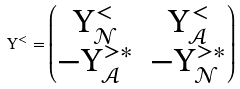Convert formula to latex. <formula><loc_0><loc_0><loc_500><loc_500>\Upsilon ^ { < } = \begin{pmatrix} \Upsilon ^ { < } _ { \mathcal { N } } & \Upsilon ^ { < } _ { \mathcal { A } } \\ - \Upsilon ^ { > \ast } _ { \mathcal { A } } & - \Upsilon ^ { > \ast } _ { \mathcal { N } } \end{pmatrix}</formula> 